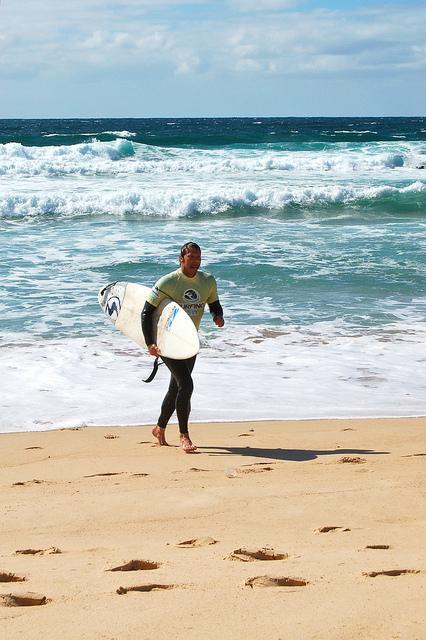How many people can you see?
Give a very brief answer. 1. How many buses are there?
Give a very brief answer. 0. 